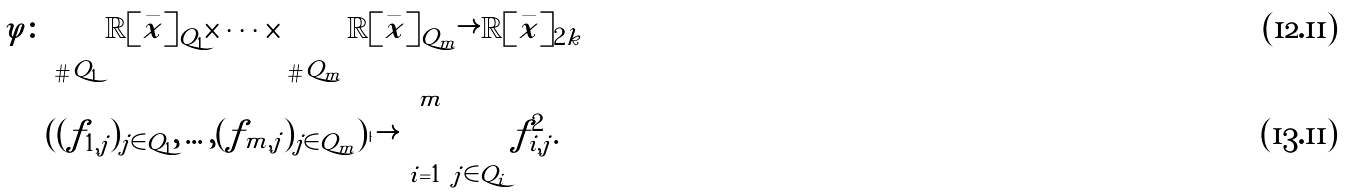Convert formula to latex. <formula><loc_0><loc_0><loc_500><loc_500>\varphi \colon & \bigoplus _ { \# Q _ { 1 } } \mathbb { R } [ \bar { x } ] _ { Q _ { 1 } } \times \cdots \times \bigoplus _ { \# Q _ { m } } \mathbb { R } [ \bar { x } ] _ { Q _ { m } } \rightarrow \mathbb { R } [ \bar { x } ] _ { 2 k } \\ & ( ( f _ { 1 , j } ) _ { j \in Q _ { 1 } } , \dots , ( f _ { m , j } ) _ { j \in Q _ { m } } ) \mapsto \sum _ { i = 1 } ^ { m } \sum _ { j \in Q _ { i } } f _ { i , j } ^ { 2 } .</formula> 